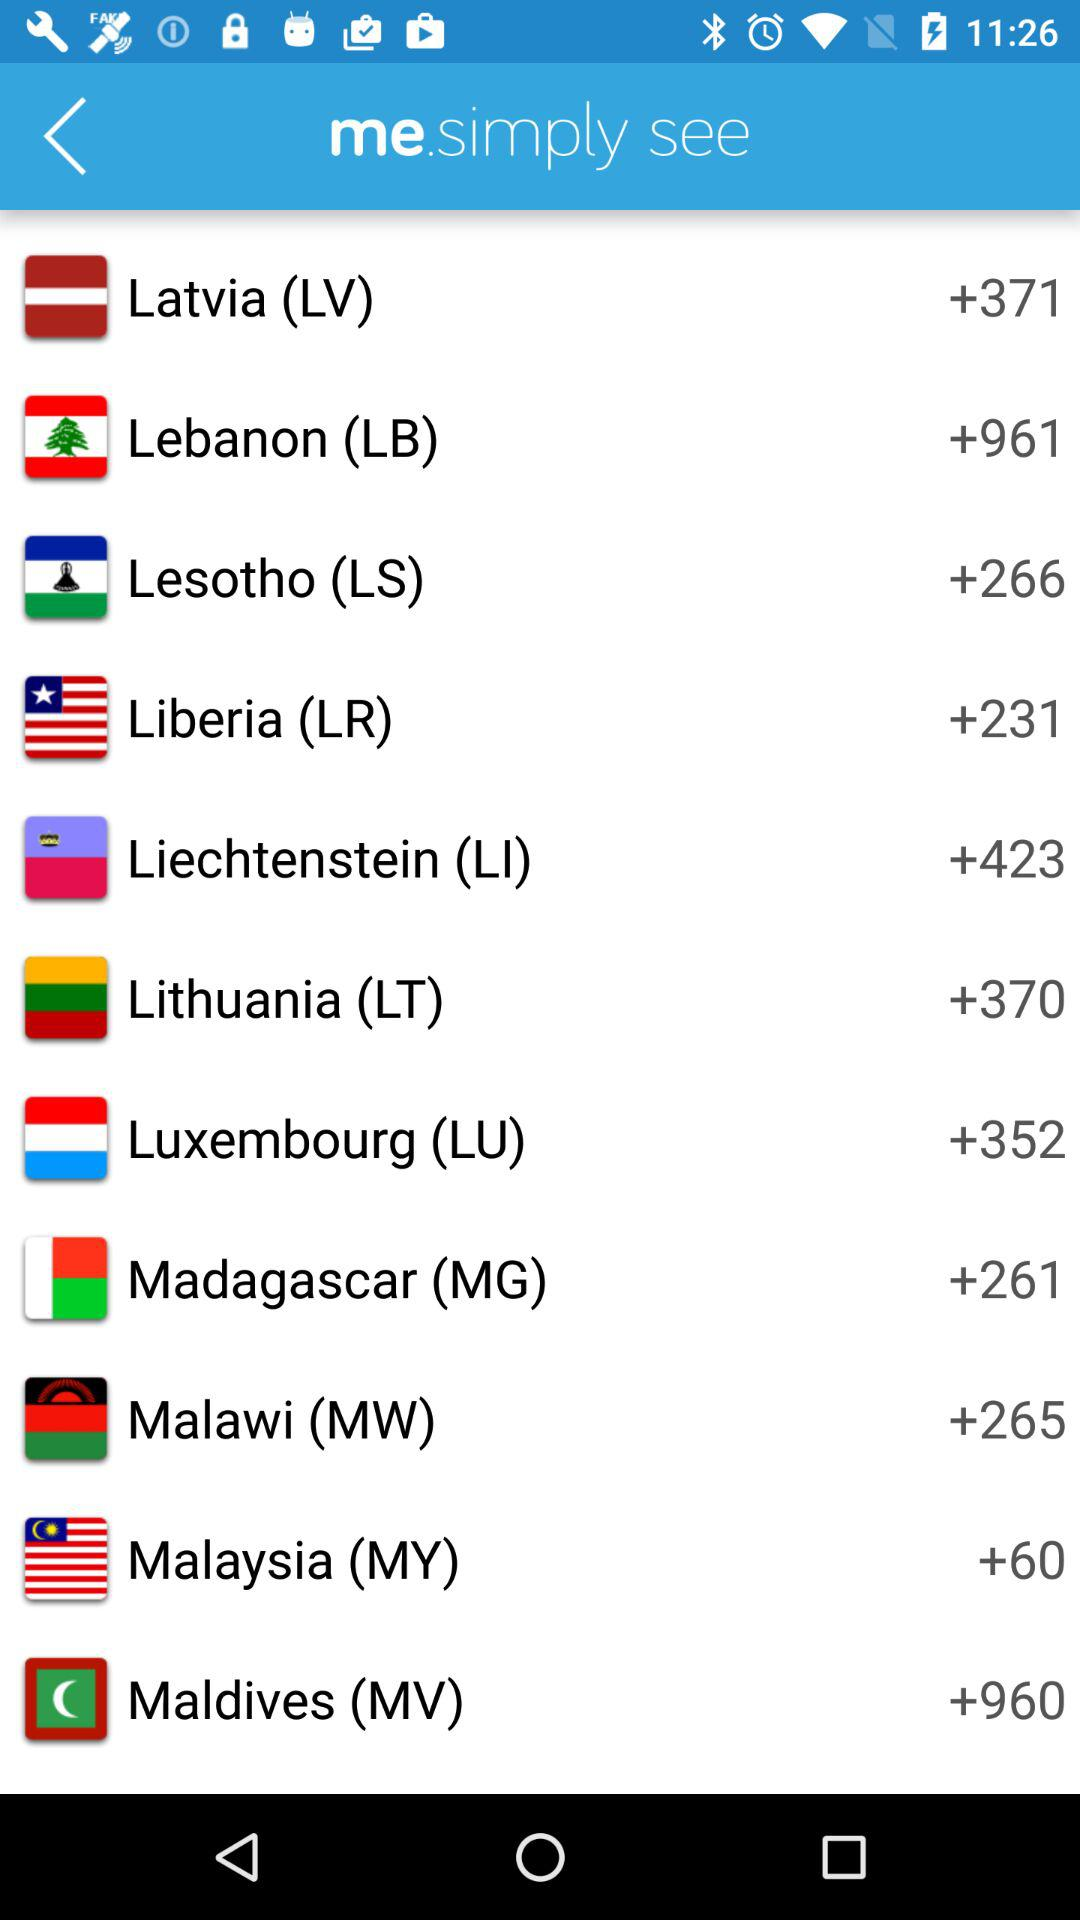What is the country code of Liberia? The country code of Liberia is +231. 